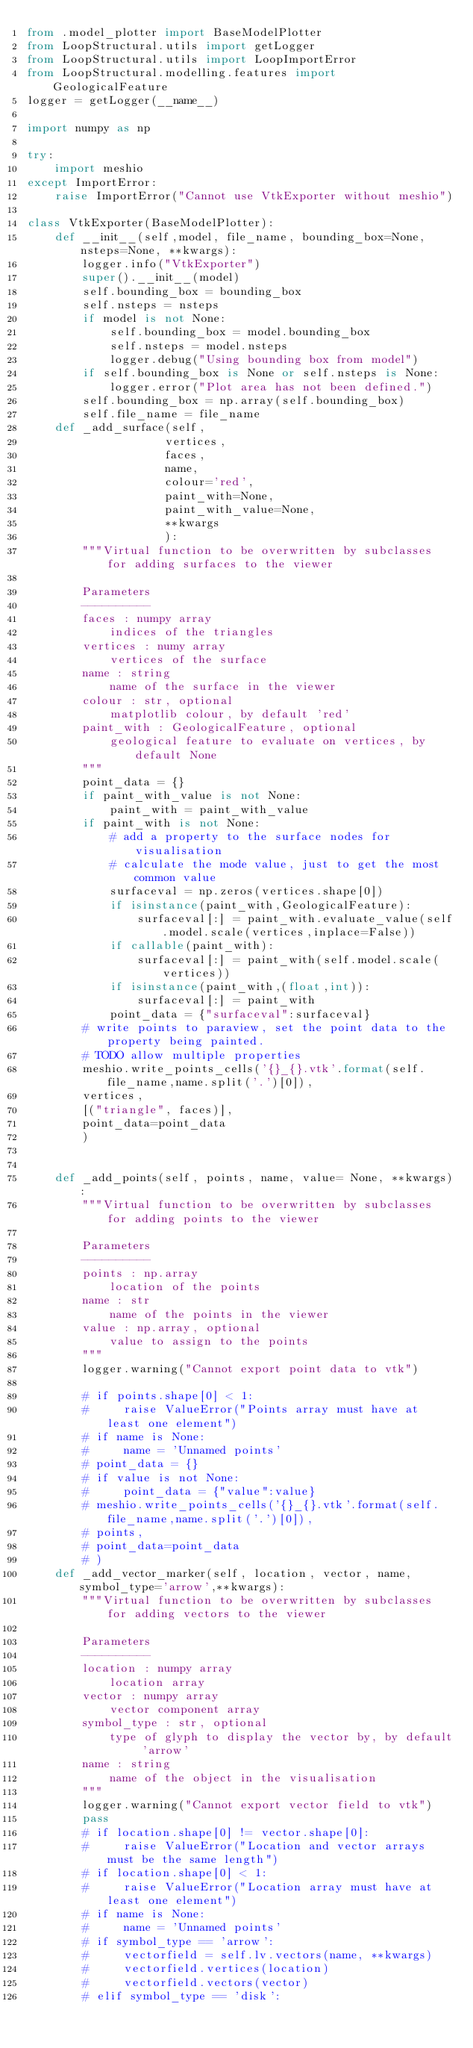<code> <loc_0><loc_0><loc_500><loc_500><_Python_>from .model_plotter import BaseModelPlotter
from LoopStructural.utils import getLogger
from LoopStructural.utils import LoopImportError
from LoopStructural.modelling.features import GeologicalFeature
logger = getLogger(__name__)

import numpy as np

try:
    import meshio
except ImportError:
    raise ImportError("Cannot use VtkExporter without meshio")

class VtkExporter(BaseModelPlotter):
    def __init__(self,model, file_name, bounding_box=None, nsteps=None, **kwargs):
        logger.info("VtkExporter")
        super().__init__(model)
        self.bounding_box = bounding_box
        self.nsteps = nsteps
        if model is not None:
            self.bounding_box = model.bounding_box
            self.nsteps = model.nsteps
            logger.debug("Using bounding box from model")
        if self.bounding_box is None or self.nsteps is None:
            logger.error("Plot area has not been defined.")
        self.bounding_box = np.array(self.bounding_box)
        self.file_name = file_name
    def _add_surface(self,
                    vertices, 
                    faces, 
                    name,
                    colour='red', 
                    paint_with=None, 
                    paint_with_value=None,
                    **kwargs
                    ):
        """Virtual function to be overwritten by subclasses for adding surfaces to the viewer

        Parameters
        ----------
        faces : numpy array
            indices of the triangles
        vertices : numy array
            vertices of the surface
        name : string
            name of the surface in the viewer
        colour : str, optional
            matplotlib colour, by default 'red'
        paint_with : GeologicalFeature, optional
            geological feature to evaluate on vertices, by default None
        """
        point_data = {}
        if paint_with_value is not None:
            paint_with = paint_with_value
        if paint_with is not None: 
            # add a property to the surface nodes for visualisation
            # calculate the mode value, just to get the most common value
            surfaceval = np.zeros(vertices.shape[0])
            if isinstance(paint_with,GeologicalFeature):
                surfaceval[:] = paint_with.evaluate_value(self.model.scale(vertices,inplace=False))
            if callable(paint_with):
                surfaceval[:] = paint_with(self.model.scale(vertices))
            if isinstance(paint_with,(float,int)):
                surfaceval[:] = paint_with
            point_data = {"surfaceval":surfaceval}
        # write points to paraview, set the point data to the property being painted. 
        # TODO allow multiple properties
        meshio.write_points_cells('{}_{}.vtk'.format(self.file_name,name.split('.')[0]),
        vertices,
        [("triangle", faces)],
        point_data=point_data
        )
        

    def _add_points(self, points, name, value= None, **kwargs):
        """Virtual function to be overwritten by subclasses for adding points to the viewer

        Parameters
        ----------
        points : np.array
            location of the points
        name : str
            name of the points in the viewer
        value : np.array, optional
            value to assign to the points
        """
        logger.warning("Cannot export point data to vtk")

        # if points.shape[0] < 1:
        #     raise ValueError("Points array must have at least one element")
        # if name is None:
        #     name = 'Unnamed points'
        # point_data = {}
        # if value is not None:
        #     point_data = {"value":value}
        # meshio.write_points_cells('{}_{}.vtk'.format(self.file_name,name.split('.')[0]),
        # points,
        # point_data=point_data
        # )
    def _add_vector_marker(self, location, vector, name, symbol_type='arrow',**kwargs):
        """Virtual function to be overwritten by subclasses for adding vectors to the viewer

        Parameters
        ----------
        location : numpy array
            location array
        vector : numpy array
            vector component array
        symbol_type : str, optional
            type of glyph to display the vector by, by default 'arrow'
        name : string
            name of the object in the visualisation
        """
        logger.warning("Cannot export vector field to vtk")
        pass
        # if location.shape[0] != vector.shape[0]:
        #     raise ValueError("Location and vector arrays must be the same length")
        # if location.shape[0] < 1:
        #     raise ValueError("Location array must have at least one element")
        # if name is None:
        #     name = 'Unnamed points'
        # if symbol_type == 'arrow':
        #     vectorfield = self.lv.vectors(name, **kwargs)
        #     vectorfield.vertices(location)
        #     vectorfield.vectors(vector)
        # elif symbol_type == 'disk':</code> 